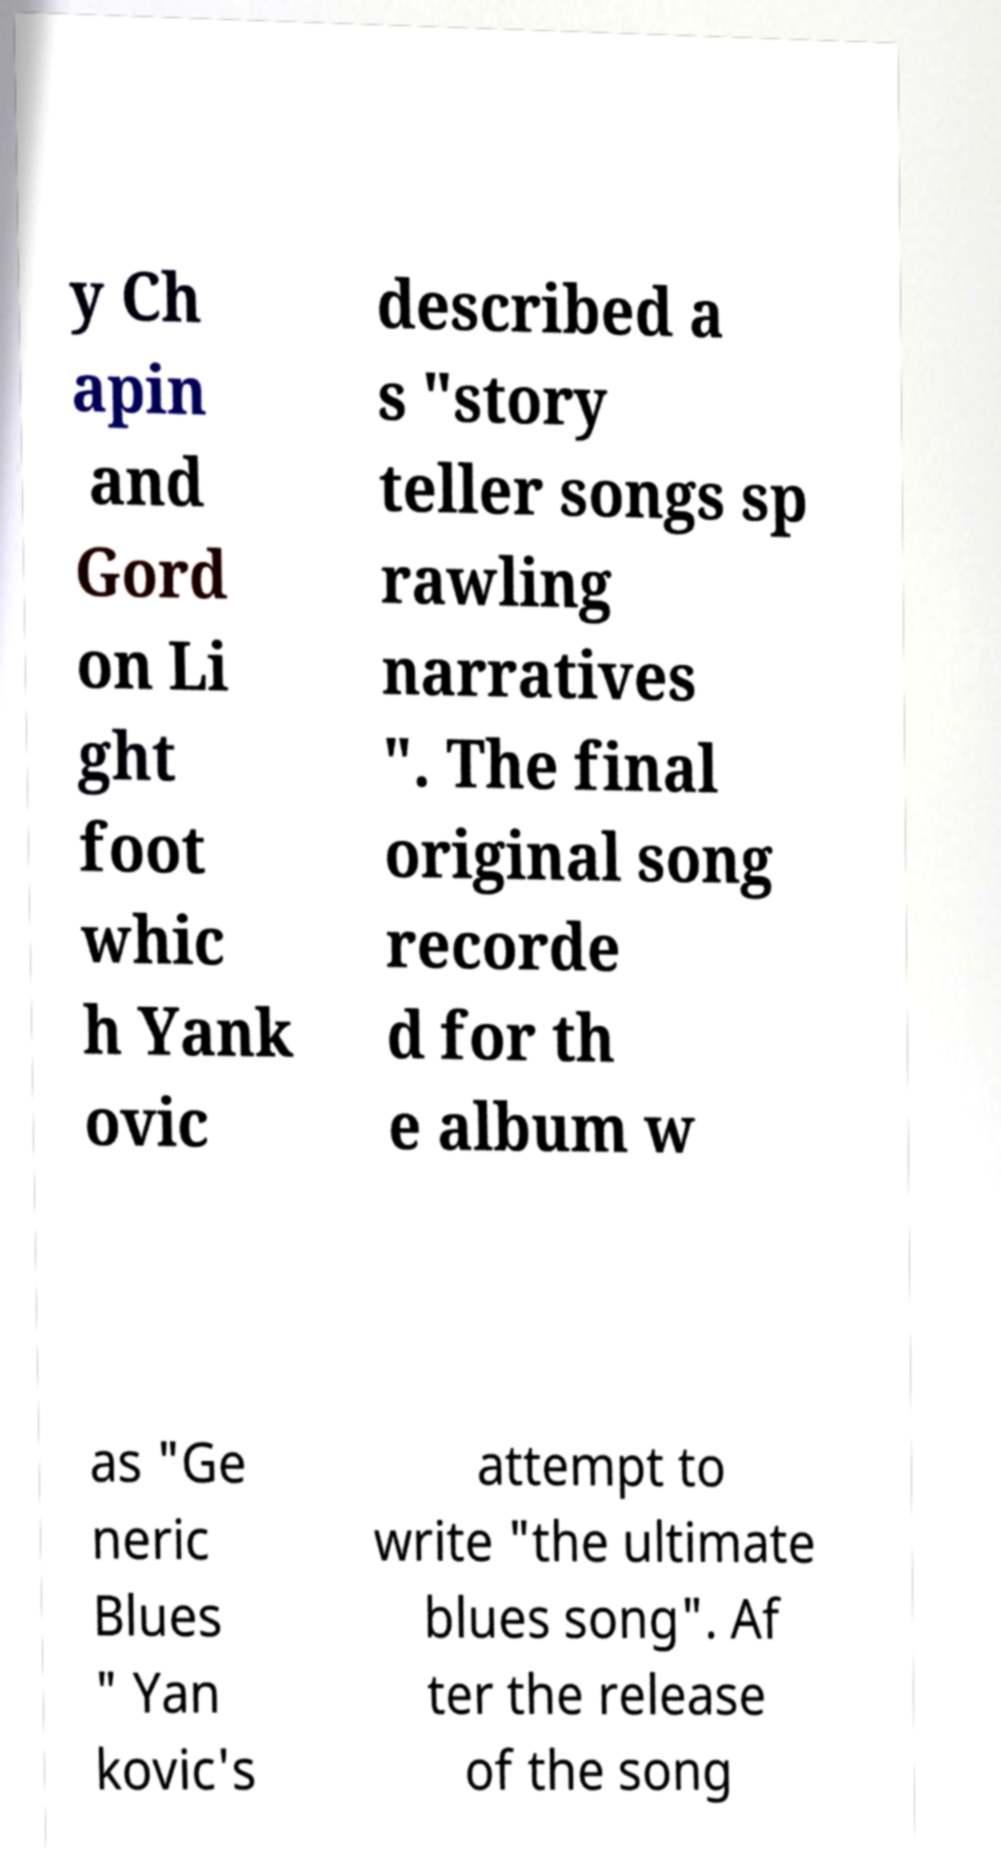Can you accurately transcribe the text from the provided image for me? y Ch apin and Gord on Li ght foot whic h Yank ovic described a s "story teller songs sp rawling narratives ". The final original song recorde d for th e album w as "Ge neric Blues " Yan kovic's attempt to write "the ultimate blues song". Af ter the release of the song 